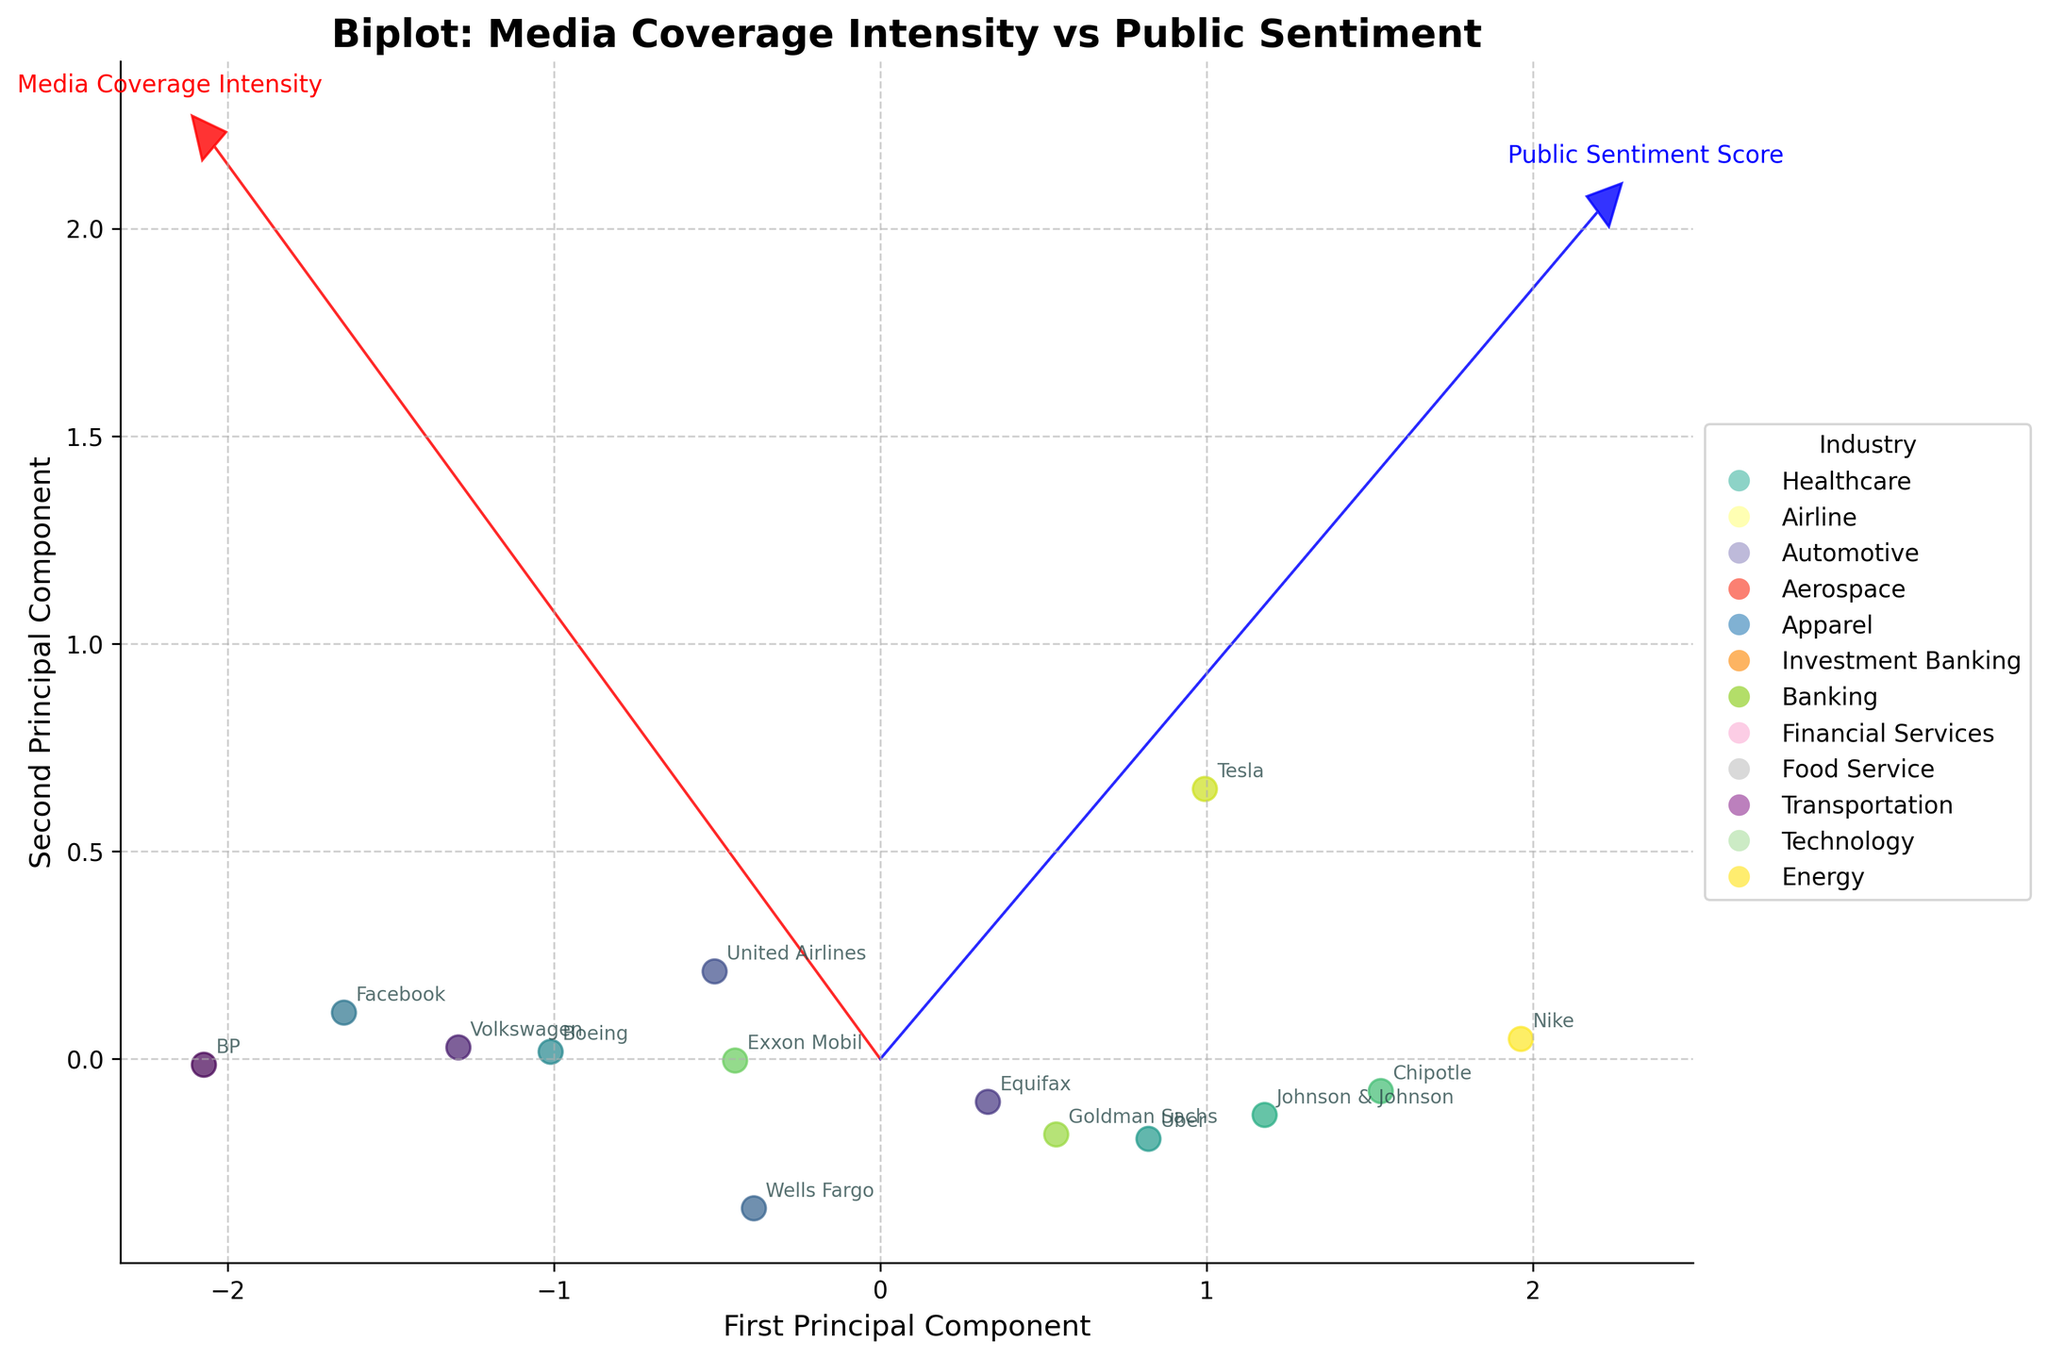Which company has the highest media coverage intensity? BP has the highest media coverage intensity as indicated by its projection value along the first principal component which is the most positive.
Answer: BP What can you deduce about the correlation between media coverage intensity and public sentiment score? The media coverage intensity and public sentiment score are negatively correlated, as indicated by the arrows pointing in roughly opposite directions in the biplot.
Answer: Negatively correlated Which industry is most represented in the biplot? The Energy industry is most represented with two companies, BP and Exxon Mobil.
Answer: Energy Which company has the lowest public sentiment score? BP has the lowest public sentiment score since its projection value along the second principal component is the most negative.
Answer: BP Compare the public sentiment scores of Volkswagen and Wells Fargo. Which one is lower? The public sentiment score of Volkswagen is lower than that of Wells Fargo since Volkswagen's projection along the second principal component is more negative than Wells Fargo's.
Answer: Volkswagen How does the transportation industry compare to the automotive industry in terms of public sentiment scores? The public sentiment score of the transportation industry (represented by Uber) is less negative than the automotive industry (represented by Volkswagen and Tesla).
Answer: Less negative Which company falls closest to the origin of the principal component axes? Nike is closest to the origin, indicating it has average values for both media coverage intensity and public sentiment score.
Answer: Nike How does the media coverage intensity of Equifax compare to that of United Airlines? Equifax has a lower media coverage intensity than United Airlines because its projection along the first principal component is less positive.
Answer: Lower What is the range of public sentiment scores represented in the biplot? The range of public sentiment scores is from approximately -8.5 (BP) to -5.5 (Nike), based on the projections of companies along the second principal component.
Answer: -8.5 to -5.5 Are companies from the Technology and Healthcare industries closely clustered in the biplot? No, Facebook (Technology) and Johnson & Johnson (Healthcare) are not closely clustered, as indicated by their different projection values in both principal components.
Answer: No 